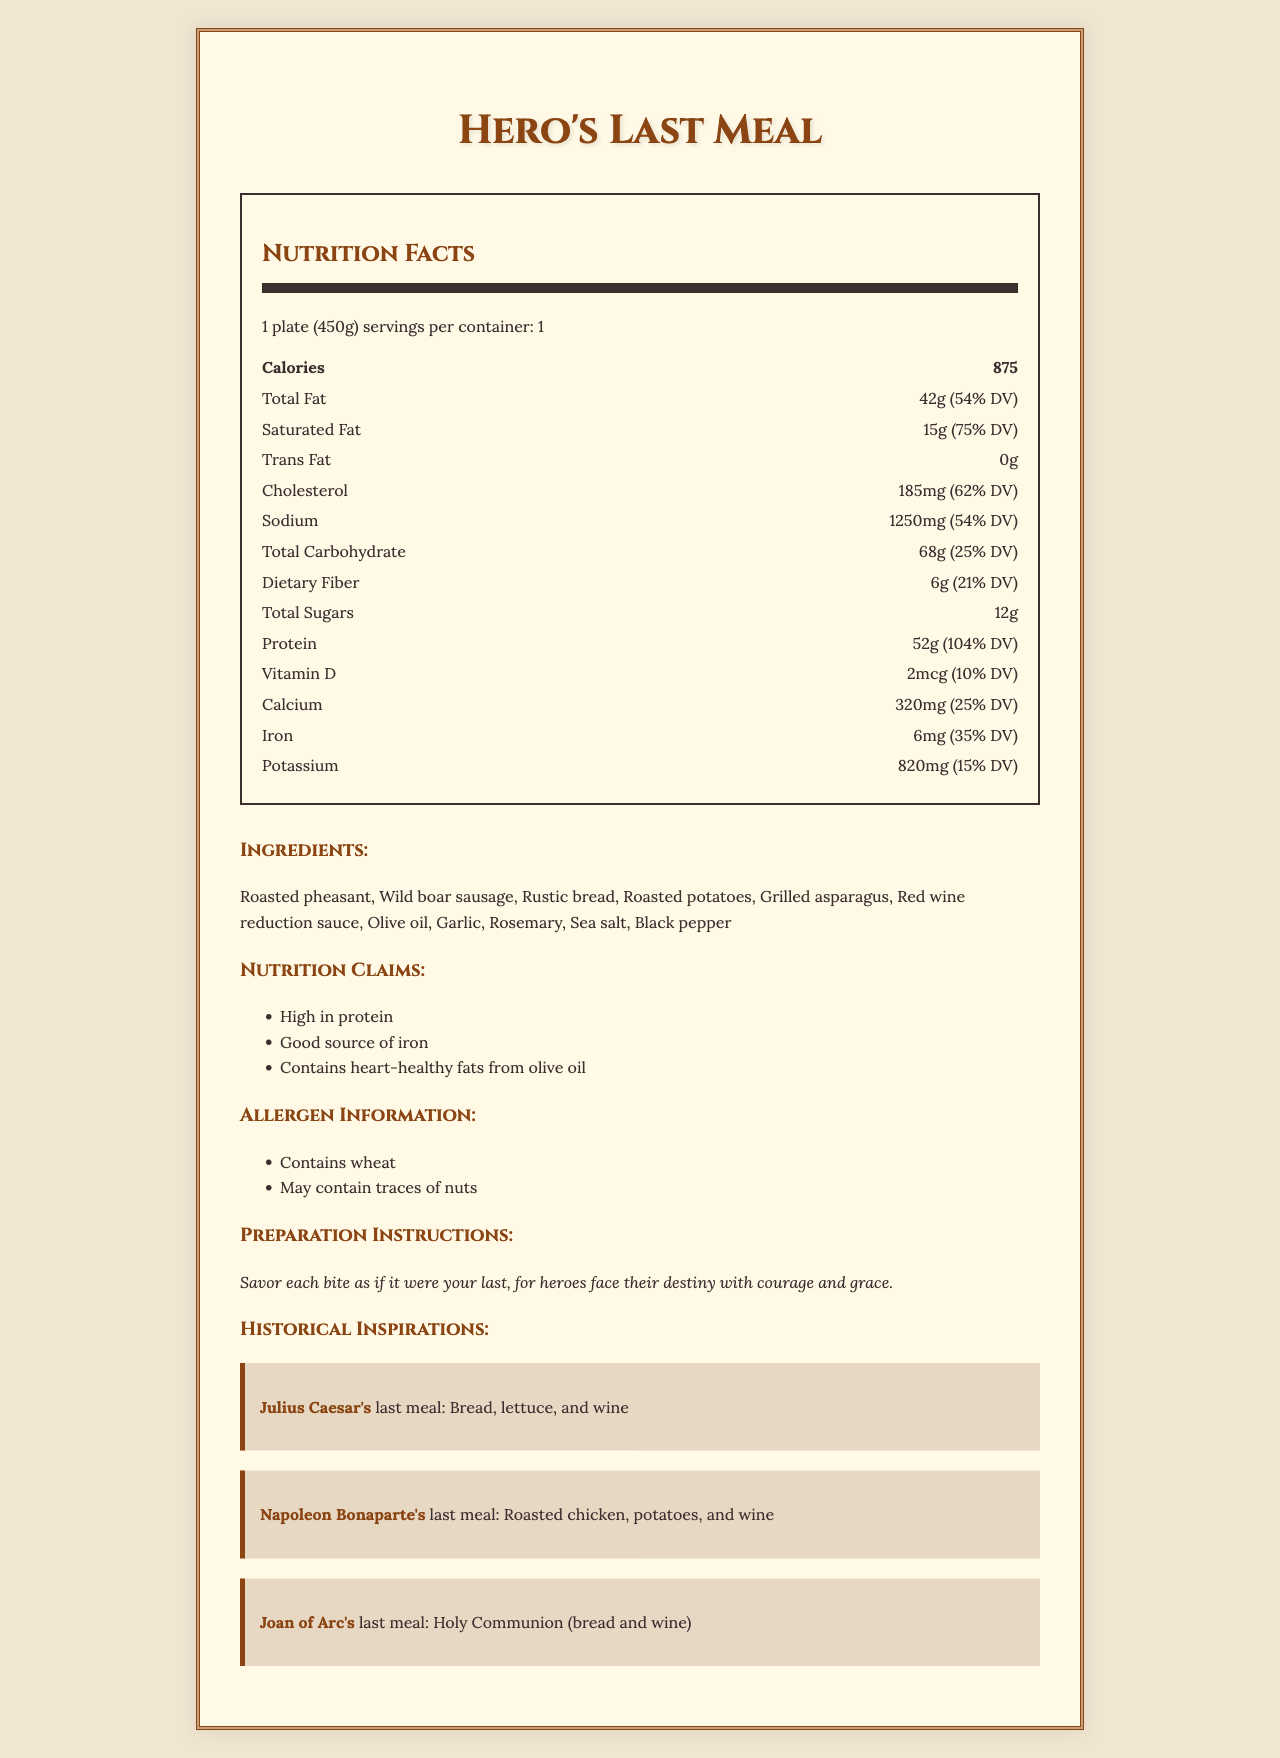What is the serving size of "Hero's Last Meal"? The serving size is specified in the document as "1 plate (450g)".
Answer: 1 plate (450g) How many calories are there in one serving of "Hero's Last Meal"? The nutrition label indicates that there are 875 calories in one serving.
Answer: 875 How much total fat is in "Hero's Last Meal"? The document lists the total fat content as 42g, which is 54% of the daily value.
Answer: 42g (54% DV) What historical figure inspired the inclusion of roasted chicken and potatoes in "Hero's Last Meal"? The historical inspirations section indicates that Napoleon Bonaparte's last meal included roasted chicken and potatoes.
Answer: Napoleon Bonaparte What allergens might be present in "Hero's Last Meal"? The allergen information section mentions that the meal contains wheat and may contain traces of nuts.
Answer: Wheat, Traces of nuts Which nutrient has the highest daily value percentage in "Hero's Last Meal"? 
   A. Calcium
   B. Protein
   C. Iron
   D. Vitamin D The nutrition facts indicate that protein has a daily value of 104%, which is the highest among the listed nutrients.
Answer: B. Protein How many grams of dietary fiber are in "Hero's Last Meal"? The document shows that the dietary fiber content is 6g, which is 21% of the daily value.
Answer: 6g (21% DV) Is the preparation instruction for "Hero's Last Meal" detailed? The preparation instruction simply advises to savor each bite as if it were your last without providing detailed steps.
Answer: No Which vitamin is mentioned in the nutrition facts of "Hero's Last Meal"? 
   I. Vitamin A
   II. Vitamin C
   III. Vitamin D
   IV. Vitamin B12 Only Vitamin D is mentioned in the nutrition facts.
Answer: III Summarize the main idea of the document. The document is designed to give a detailed overview of "Hero's Last Meal," its nutritional content, ingredients, and ties to historical meals.
Answer: The document provides comprehensive nutritional information for a fictional meal, "Hero's Last Meal," inspired by the last suppers of historical heroes. It includes serving size, calorie count, macro and micronutrient content, allergen information, historical inspirations, and brief preparation instructions. What is the primary ingredient in "Hero's Last Meal" inspired by Julius Caesar's last meal? The historical inspirations section mentions that Julius Caesar's last meal included bread.
Answer: Bread What is the total carbohydrate content in "Hero's Last Meal"? The document lists the total carbohydrate content as 68g, 25% of the daily value.
Answer: 68g (25% DV) True or False: "Hero's Last Meal" is high in trans fat. The nutrition facts specify that the meal contains 0g of trans fat.
Answer: False Who most likely would find "Hero's Last Meal" appealing due to its historical inspirations, according to the document? The historical inspirations highlight famous last meals, likely appealing to those fascinated by heroism in history.
Answer: People interested in heroic historical figures What is the calcium content and its daily value percentage in "Hero's Last Meal"? The nutrition facts indicate that the calcium content is 320mg, which is 25% of the daily value.
Answer: 320mg (25% DV) Could "Hero's Last Meal" be considered low in sodium? The sodium content is 1250mg, which is 54% of the daily value, indicating it is not low in sodium.
Answer: No Does "Hero's Last Meal" contain added sugars? The document lists total sugars but does not specify whether they include added sugars.
Answer: Not mentioned 